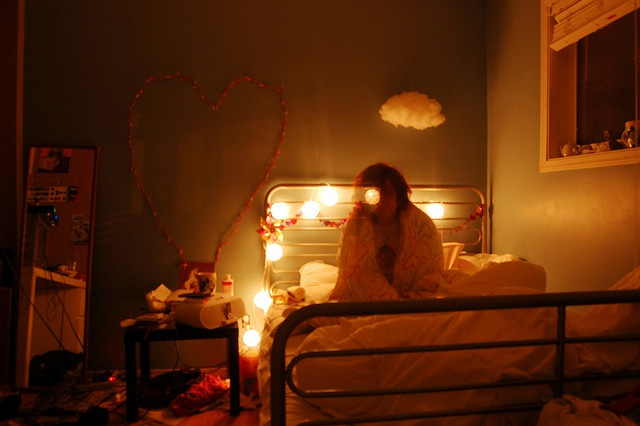Describe the objects in this image and their specific colors. I can see bed in black, maroon, and red tones and people in black, maroon, and brown tones in this image. 